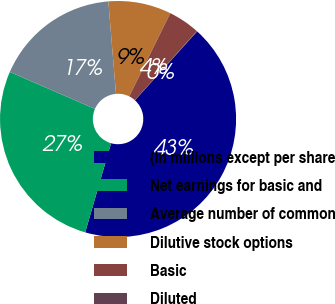Convert chart to OTSL. <chart><loc_0><loc_0><loc_500><loc_500><pie_chart><fcel>(In millions except per share<fcel>Net earnings for basic and<fcel>Average number of common<fcel>Dilutive stock options<fcel>Basic<fcel>Diluted<nl><fcel>42.8%<fcel>27.04%<fcel>17.16%<fcel>8.61%<fcel>4.33%<fcel>0.06%<nl></chart> 